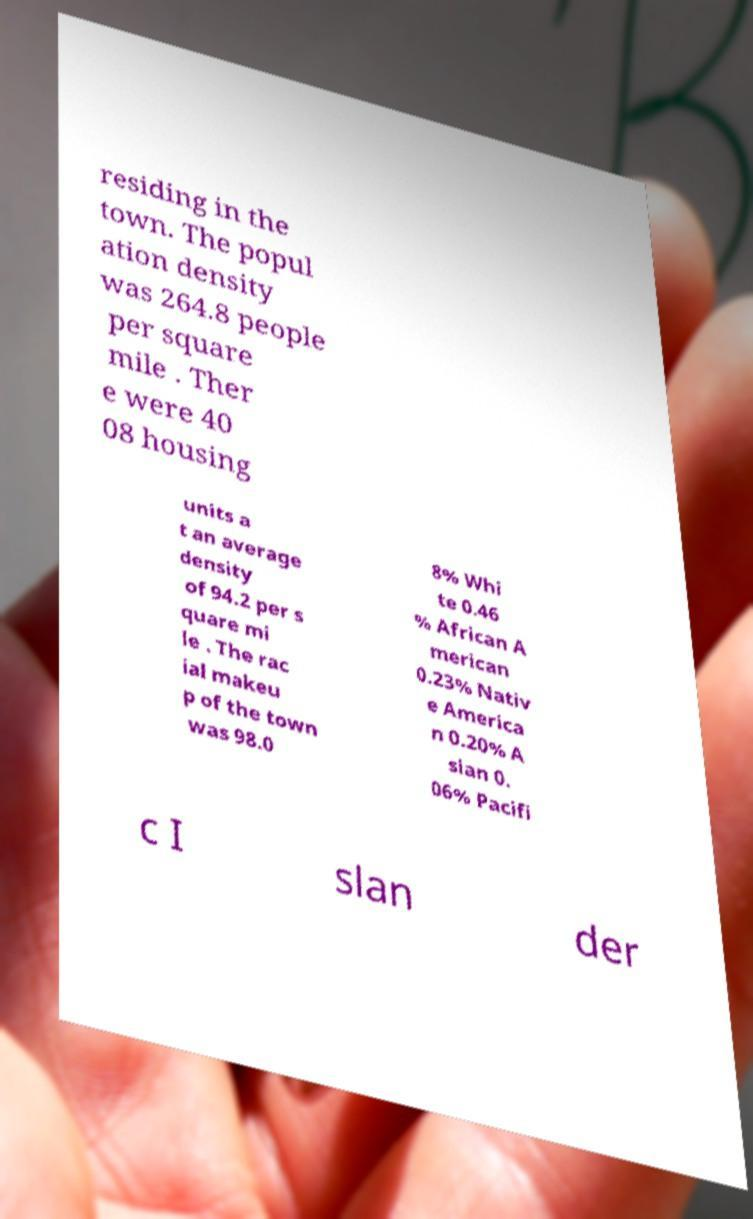Can you read and provide the text displayed in the image?This photo seems to have some interesting text. Can you extract and type it out for me? residing in the town. The popul ation density was 264.8 people per square mile . Ther e were 40 08 housing units a t an average density of 94.2 per s quare mi le . The rac ial makeu p of the town was 98.0 8% Whi te 0.46 % African A merican 0.23% Nativ e America n 0.20% A sian 0. 06% Pacifi c I slan der 